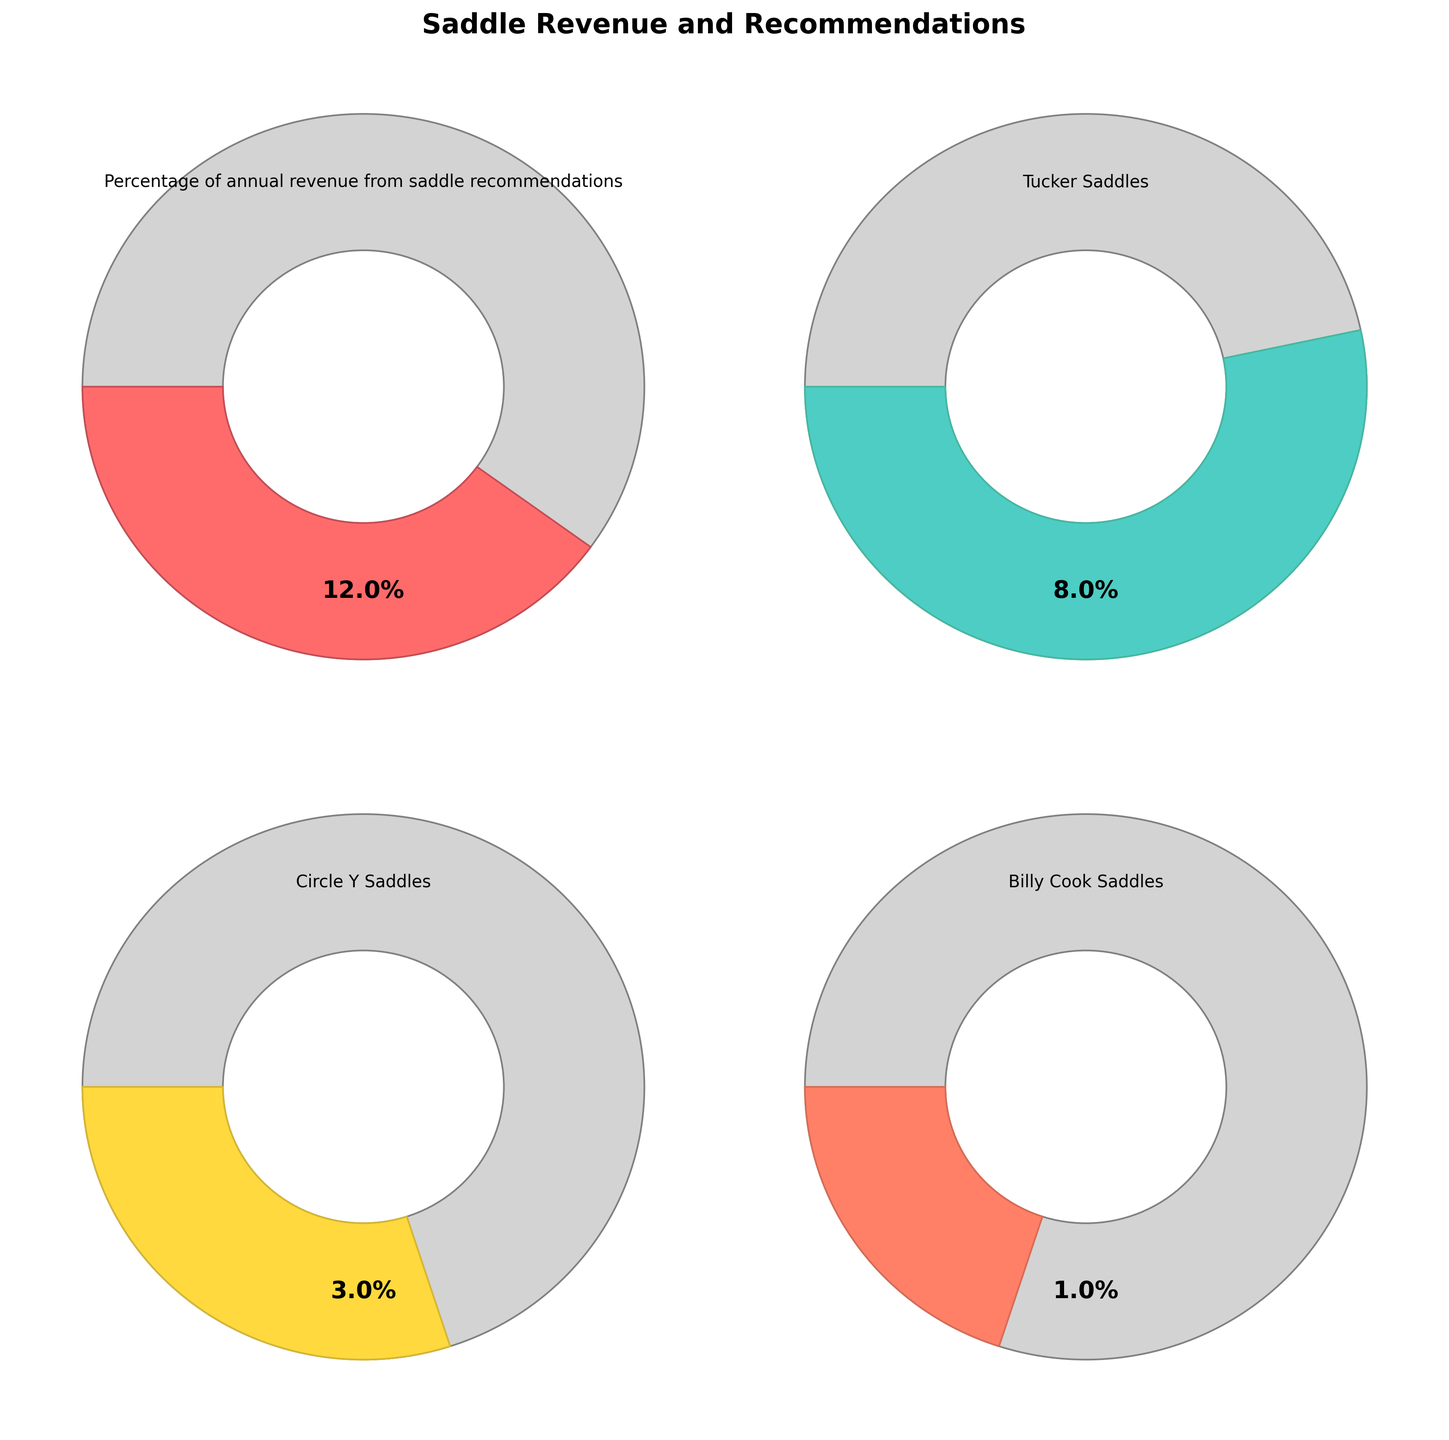What's the title of the figure? The title of the figure can be found at the top of the chart. In this case, it reads "Saddle Revenue and Recommendations".
Answer: "Saddle Revenue and Recommendations" What percentage of annual revenue comes from Tucker Saddles? Locate the chart labeled "Tucker Saddles" and refer to the number displayed inside the gauge chart. It shows a percentage value. The value for Tucker Saddles is 8%.
Answer: 8% What is the combined percentage of annual revenue from Circle Y Saddles and Billy Cook Saddles? Add the percentages for Circle Y Saddles (3%) and Billy Cook Saddles (1%) together. The combined percentage is 3% + 1% = 4%.
Answer: 4% Which saddle brand contributes the least to the annual revenue? Compare the percentage values shown on the gauge charts for each saddle brand. The saddle brand with the smallest percentage is Billy Cook Saddles, at 1%.
Answer: Billy Cook Saddles Which brand's revenue percentage is closest to its maximum possible value as shown in the chart? Analyze the gauge charts to compare which brand's value is closest to its given maximum. Billy Cook Saddles has a value of 1 and a max of 5 (20% of the max), Circle Y Saddles has 3 out of 10 (30% of the max), and Tucker Saddles has 8 out of 15 (53.3% of the max). Tucker Saddles' revenue percentage is closest to its maximum possible value.
Answer: Tucker Saddles How does the overall percentage of annual revenue from saddle recommendations compare to the individual brands? The overall percentage from saddle recommendations is given as 12%. Comparing this to the individual contributions: Tucker Saddles (8%), Circle Y Saddles (3%), and Billy Cook Saddles (1%). The sum of the individual contributions (8% + 3% + 1% = 12%) matches the overall percentage.
Answer: They match Which brand's recommendation percentage exceeds half of its possible maximum value? Check the values relative to their maximums. Half of the maximum for Tucker Saddles is 7.5 (8 > 7.5); Circle Y Saddles' half maximum is 5 (3 < 5) and for Billy Cook Saddles it's 2.5 (1 < 2.5). Only Tucker Saddles exceeds half of its maximum value.
Answer: Tucker Saddles 